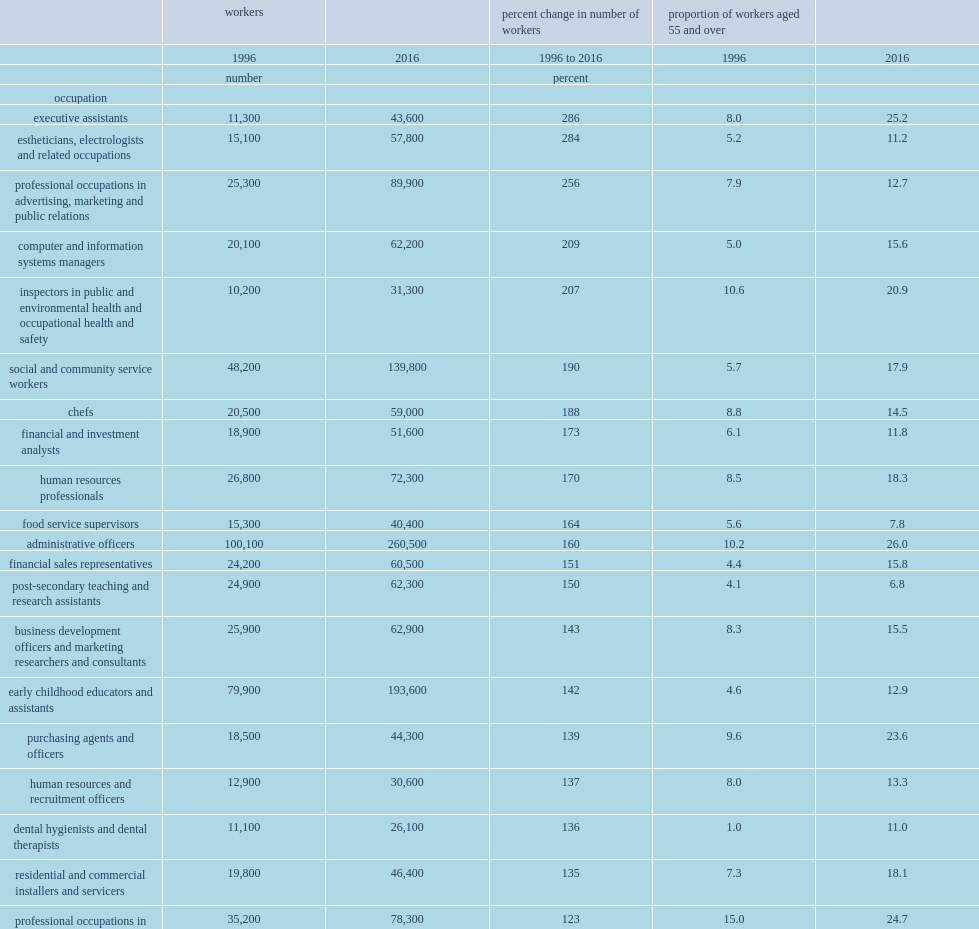By what percentage did the number of workers in professional occupations in advertising, marketing and public relations increase between 1996 and 2016? 256.0. By what percentage did the number of computer and information systems managers increase between 1996 and 2016? 209.0. By what percentage did the number of inspectors in public and environmental health and occupational health and safety increase between 1996 and 2016? 207.0. What is the percentage of older workers in professional occupations in advertising, marketing and public relations in 1996? 7.9. What is the percentage of older workers in professional occupations in advertising, marketing and public relations in 2016? 12.7. 